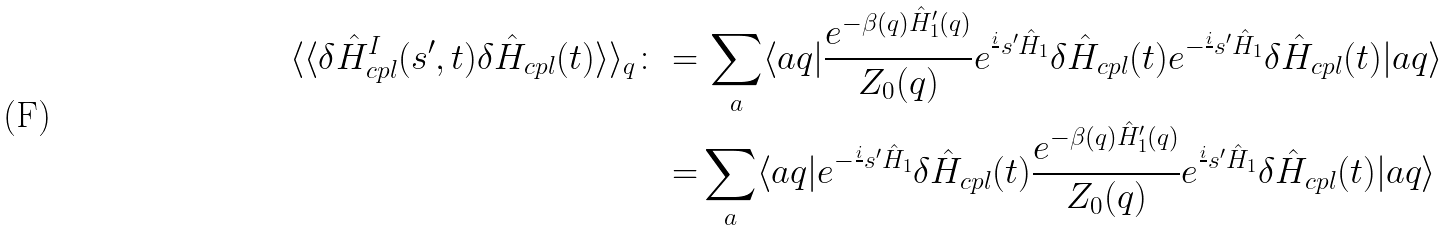<formula> <loc_0><loc_0><loc_500><loc_500>\langle \langle \delta \hat { H } ^ { I } _ { c p l } ( s ^ { \prime } , t ) \delta \hat { H } _ { c p l } ( t ) \rangle \rangle _ { q } \colon = & \, \sum _ { a } \langle a q | \frac { e ^ { - \beta ( q ) \hat { H } ^ { \prime } _ { 1 } ( q ) } } { Z _ { 0 } ( q ) } e ^ { \frac { i } { } s ^ { \prime } \hat { H } _ { 1 } } \delta \hat { H } _ { c p l } ( t ) e ^ { - \frac { i } { } s ^ { \prime } \hat { H } _ { 1 } } \delta \hat { H } _ { c p l } ( t ) | a q \rangle \\ = & \sum _ { a } \langle a q | e ^ { - \frac { i } { } s ^ { \prime } \hat { H } _ { 1 } } \delta \hat { H } _ { c p l } ( t ) \frac { e ^ { - \beta ( q ) \hat { H } ^ { \prime } _ { 1 } ( q ) } } { Z _ { 0 } ( q ) } e ^ { \frac { i } { } s ^ { \prime } \hat { H } _ { 1 } } \delta \hat { H } _ { c p l } ( t ) | a q \rangle</formula> 